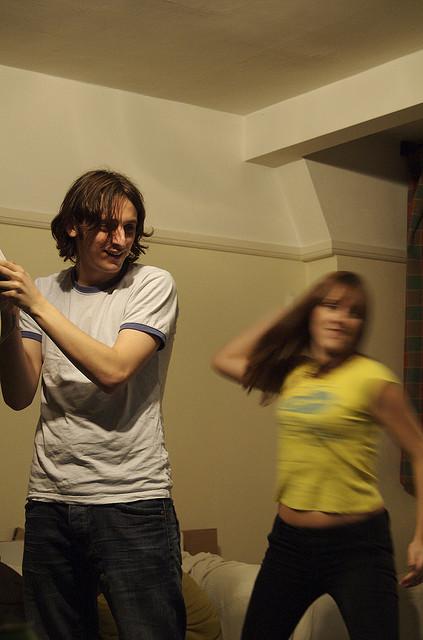What is the man and woman doing?
Answer briefly. Playing wii. What are the people doing?
Write a very short answer. Playing wii. Is the woman in the yellow shirts stomach showing?
Keep it brief. Yes. What color tags do the women playing the game have?
Give a very brief answer. Yellow. 